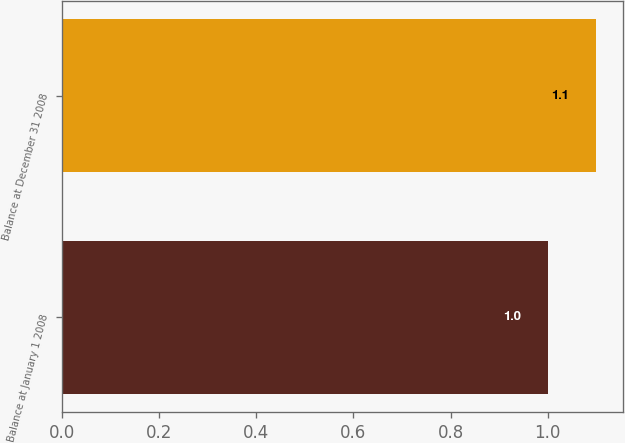Convert chart to OTSL. <chart><loc_0><loc_0><loc_500><loc_500><bar_chart><fcel>Balance at January 1 2008<fcel>Balance at December 31 2008<nl><fcel>1<fcel>1.1<nl></chart> 